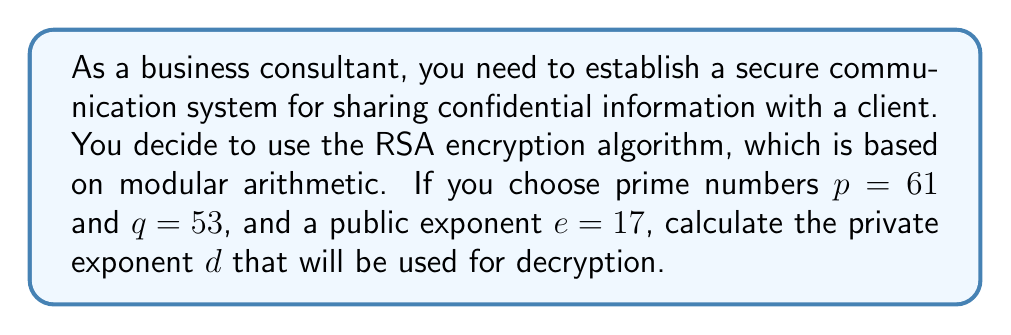Teach me how to tackle this problem. To solve this problem, we'll follow these steps using modular arithmetic:

1) First, calculate $n = p \times q$:
   $n = 61 \times 53 = 3233$

2) Calculate $\phi(n) = (p-1) \times (q-1)$:
   $\phi(n) = 60 \times 52 = 3120$

3) The private exponent $d$ is the modular multiplicative inverse of $e$ modulo $\phi(n)$. We need to find $d$ such that:

   $e \times d \equiv 1 \pmod{\phi(n)}$

   Or: $17d \equiv 1 \pmod{3120}$

4) We can use the extended Euclidean algorithm to find $d$:

   $3120 = 183 \times 17 + 9$
   $17 = 1 \times 9 + 8$
   $9 = 1 \times 8 + 1$
   $8 = 8 \times 1 + 0$

   Working backwards:
   $1 = 9 - 1 \times 8$
   $1 = 9 - 1 \times (17 - 1 \times 9) = 2 \times 9 - 1 \times 17$
   $1 = 2 \times (3120 - 183 \times 17) - 1 \times 17$
   $1 = 2 \times 3120 - 367 \times 17$

5) Therefore, $d \equiv -367 \pmod{3120}$

6) To get a positive value less than 3120, we add 3120:
   $d = -367 + 3120 = 2753$

7) Verify: $17 \times 2753 = 46801 \equiv 1 \pmod{3120}$

Thus, the private exponent $d$ is 2753.
Answer: $d = 2753$ 